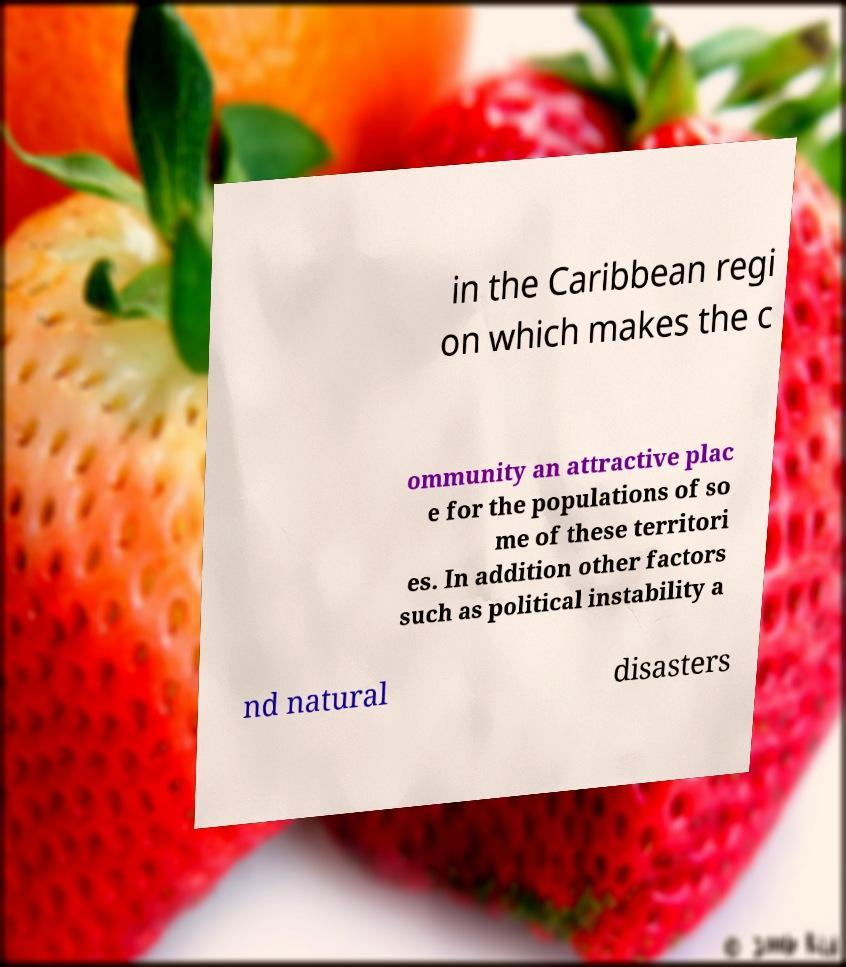Can you accurately transcribe the text from the provided image for me? in the Caribbean regi on which makes the c ommunity an attractive plac e for the populations of so me of these territori es. In addition other factors such as political instability a nd natural disasters 